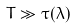<formula> <loc_0><loc_0><loc_500><loc_500>T \gg \tau ( \lambda )</formula> 